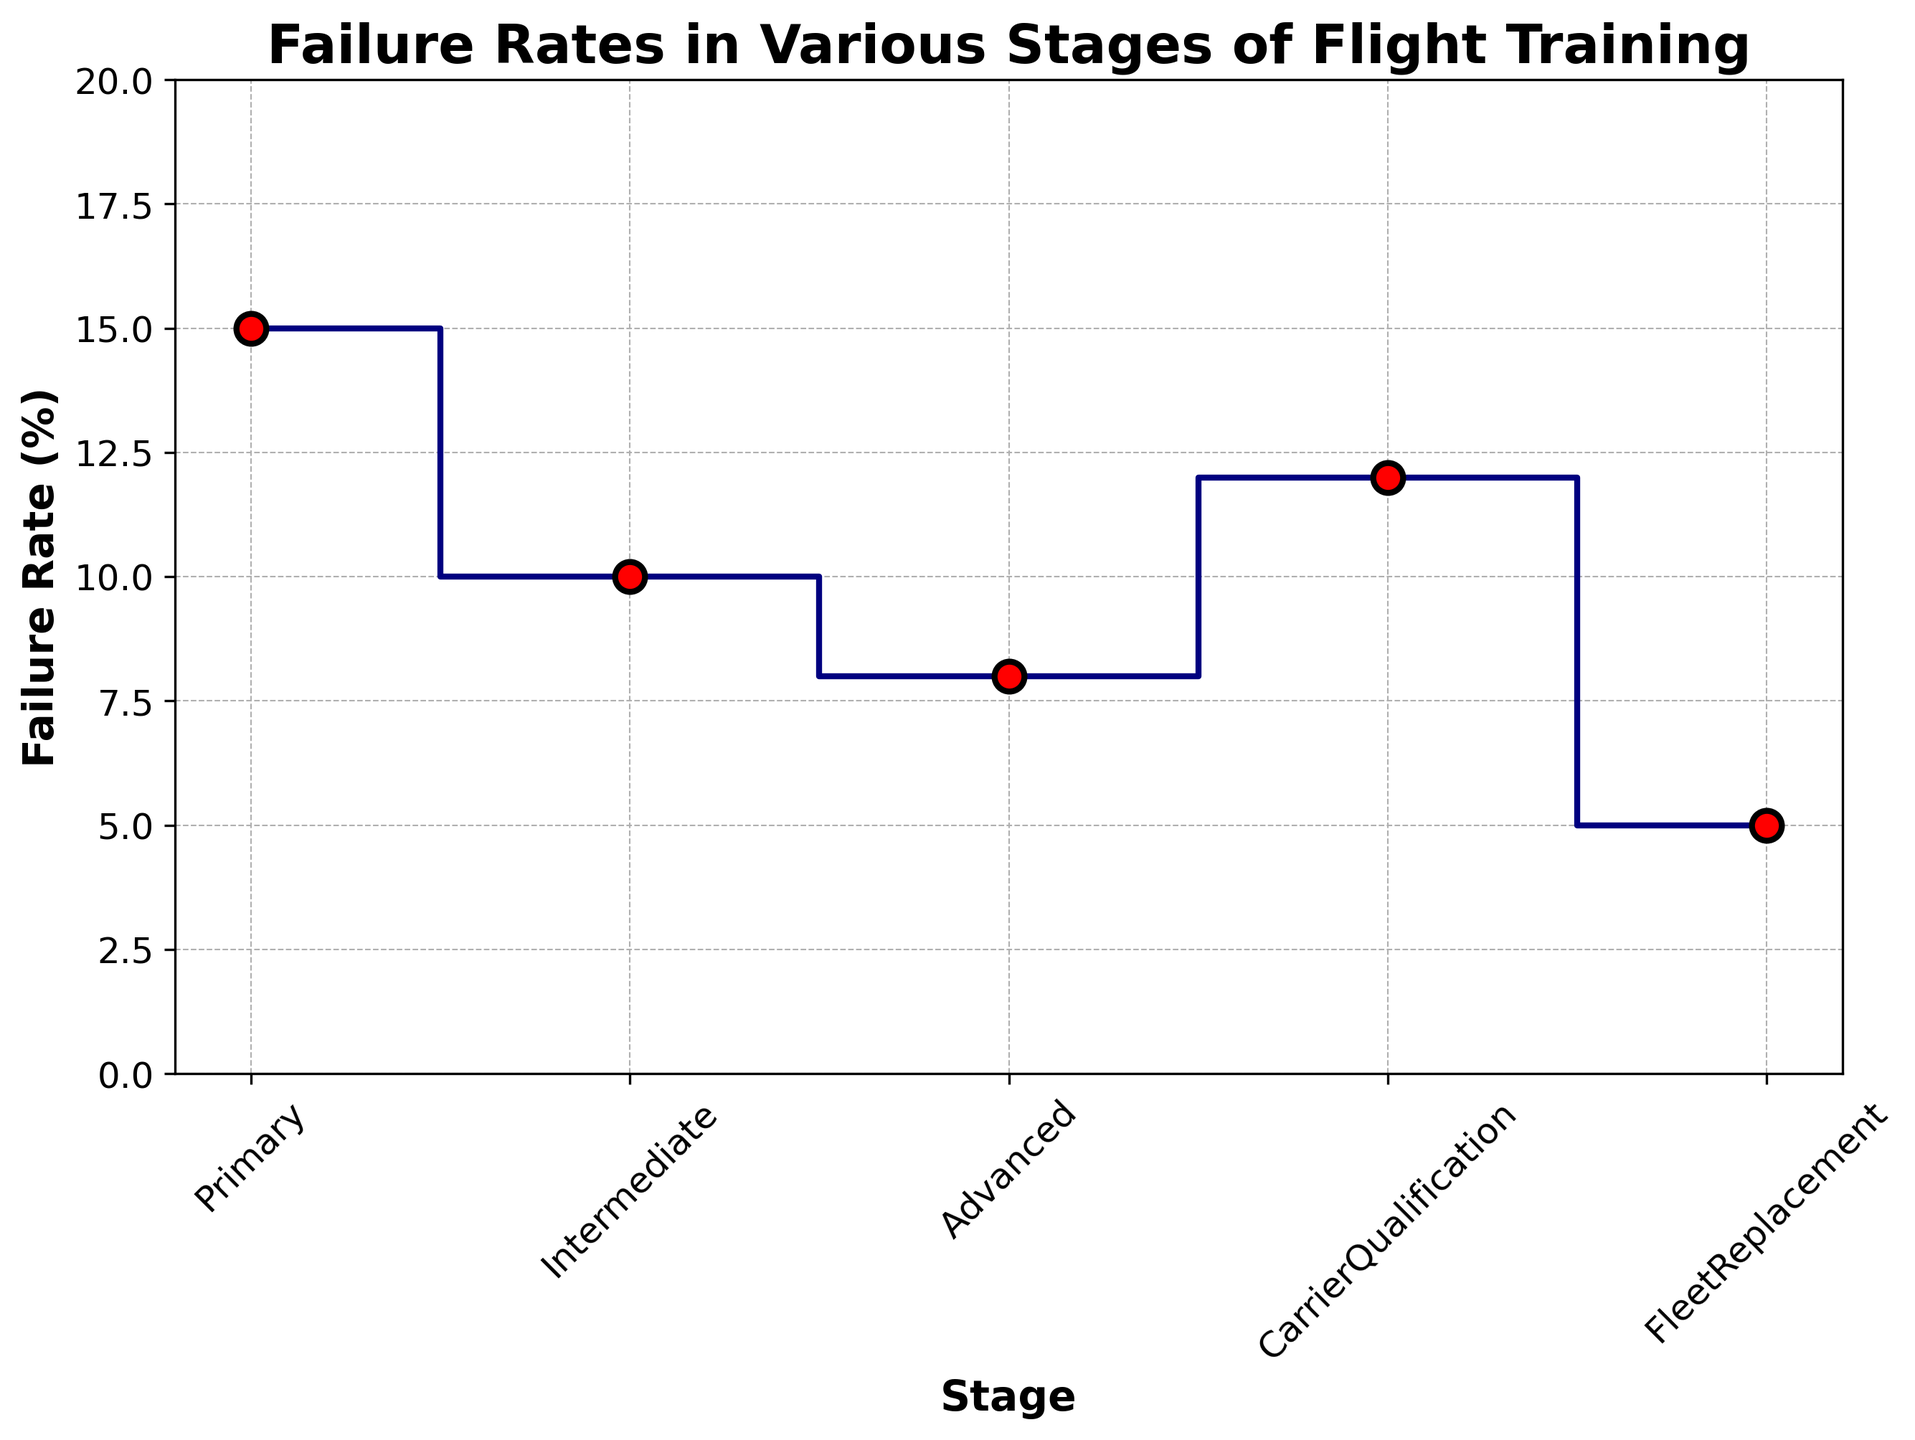What is the failure rate at the Primary stage? The figure shows the failure rate at each stage. The Primary stage is labeled first, and its failure rate is identified on the y-axis.
Answer: 15% What is the difference in failure rates between the Intermediate and Advanced stages? The figure shows the failure rate for the Intermediate stage is 10% and for the Advanced stage is 8%. Subtract the smaller from the larger failure rate: 10% - 8% = 2%.
Answer: 2% Which stage has the highest failure rate? By visually inspecting the heights of the steps in the plot, the Primary stage has the highest value on the y-axis, which indicates the highest failure rate.
Answer: Primary What is the average failure rate across all stages? To calculate the average, sum the failure rates of all stages and divide by the number of stages: (15 + 10 + 8 + 12 + 5) / 5 = 50 / 5 = 10%.
Answer: 10% How does the failure rate at the Fleet Replacement stage compare to the Carrier Qualification stage? The figure shows the failure rate at the Fleet Replacement stage is 5%, and at the Carrier Qualification stage, it is 12%. Therefore, the rate at the Fleet Replacement stage is lower.
Answer: Fleet Replacement is lower Which two stages have the smallest difference in failure rates? By comparing the values visually, the Intermediate stage (10%) and Advanced stage (8%) differ by only 2%, which is smaller than the differences between other consecutive stages.
Answer: Intermediate and Advanced What is the total failure rate for all stages combined? Sum the failure rates shown at each stage: 15% + 10% + 8% + 12% + 5% = 50%.
Answer: 50% Is there a stage where the failure rate is less than 10%? If so, which stage? By inspecting the figure, both the Advanced stage (8%) and Fleet Replacement stage (5%) have failure rates less than 10%.
Answer: Advanced and Fleet Replacement By how much does the failure rate drop from the Primary stage to the Fleet Replacement stage? The Primary stage has a failure rate of 15%, and the Fleet Replacement stage has a rate of 5%. Subtract the Fleet Replacement stage rate from the Primary stage rate: 15% - 5% = 10%.
Answer: 10% Which stage has a failure rate depicted with the largest red circle marker? Since the marker size seems consistent across stages, they all appear to have the same sized red circle markers; however, the Primary stage marker stands out because it represents the highest y-axis value (failure rate).
Answer: Primary 